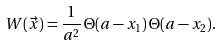<formula> <loc_0><loc_0><loc_500><loc_500>W ( \vec { x } ) = \frac { 1 } { a ^ { 2 } } \, \Theta ( a - x _ { 1 } ) \, \Theta ( a - x _ { 2 } ) .</formula> 